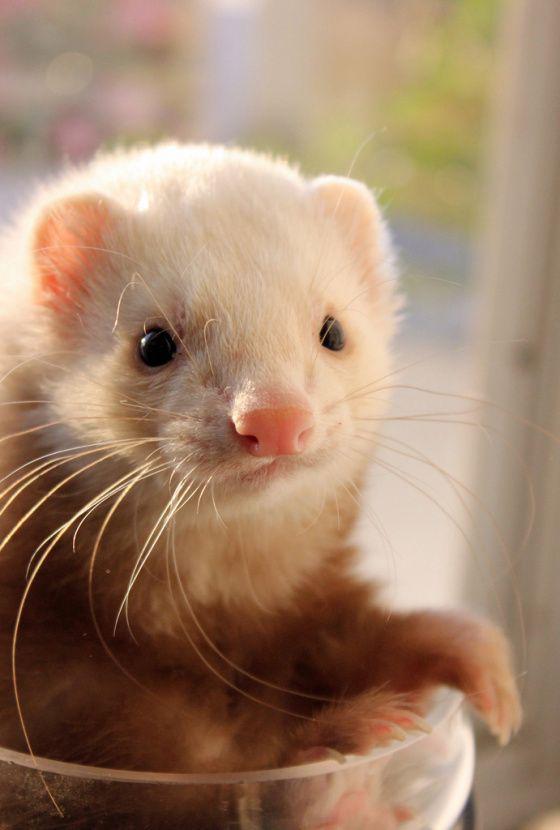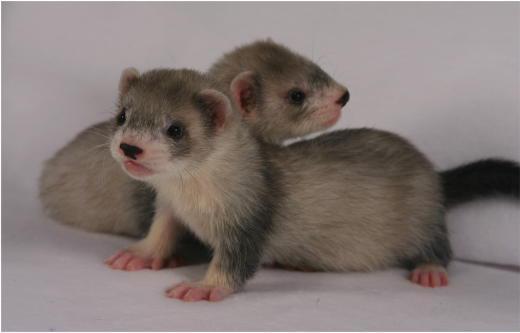The first image is the image on the left, the second image is the image on the right. For the images shown, is this caption "One of the images shows an animal being held by a human." true? Answer yes or no. No. The first image is the image on the left, the second image is the image on the right. Assess this claim about the two images: "There is only one ferret in each of the images.". Correct or not? Answer yes or no. No. 